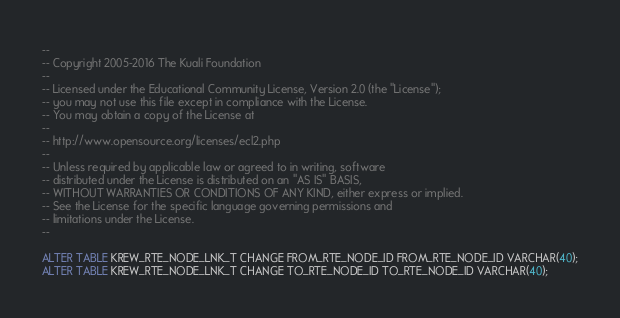Convert code to text. <code><loc_0><loc_0><loc_500><loc_500><_SQL_>--
-- Copyright 2005-2016 The Kuali Foundation
--
-- Licensed under the Educational Community License, Version 2.0 (the "License");
-- you may not use this file except in compliance with the License.
-- You may obtain a copy of the License at
--
-- http://www.opensource.org/licenses/ecl2.php
--
-- Unless required by applicable law or agreed to in writing, software
-- distributed under the License is distributed on an "AS IS" BASIS,
-- WITHOUT WARRANTIES OR CONDITIONS OF ANY KIND, either express or implied.
-- See the License for the specific language governing permissions and
-- limitations under the License.
--

ALTER TABLE KREW_RTE_NODE_LNK_T CHANGE FROM_RTE_NODE_ID FROM_RTE_NODE_ID VARCHAR(40);
ALTER TABLE KREW_RTE_NODE_LNK_T CHANGE TO_RTE_NODE_ID TO_RTE_NODE_ID VARCHAR(40);
</code> 